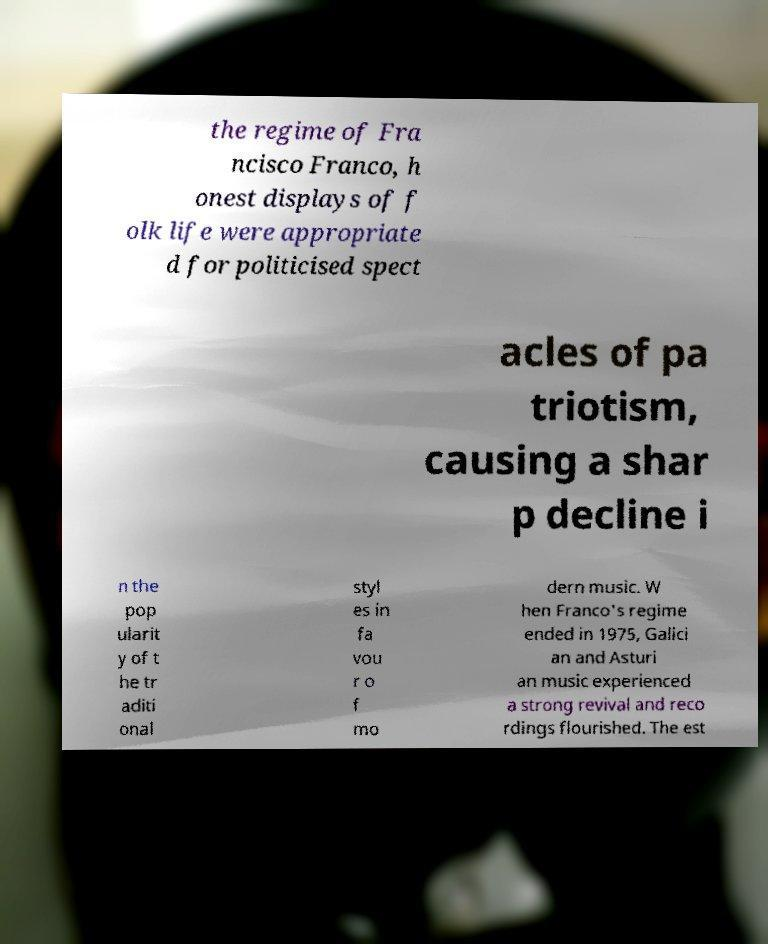Please read and relay the text visible in this image. What does it say? the regime of Fra ncisco Franco, h onest displays of f olk life were appropriate d for politicised spect acles of pa triotism, causing a shar p decline i n the pop ularit y of t he tr aditi onal styl es in fa vou r o f mo dern music. W hen Franco's regime ended in 1975, Galici an and Asturi an music experienced a strong revival and reco rdings flourished. The est 